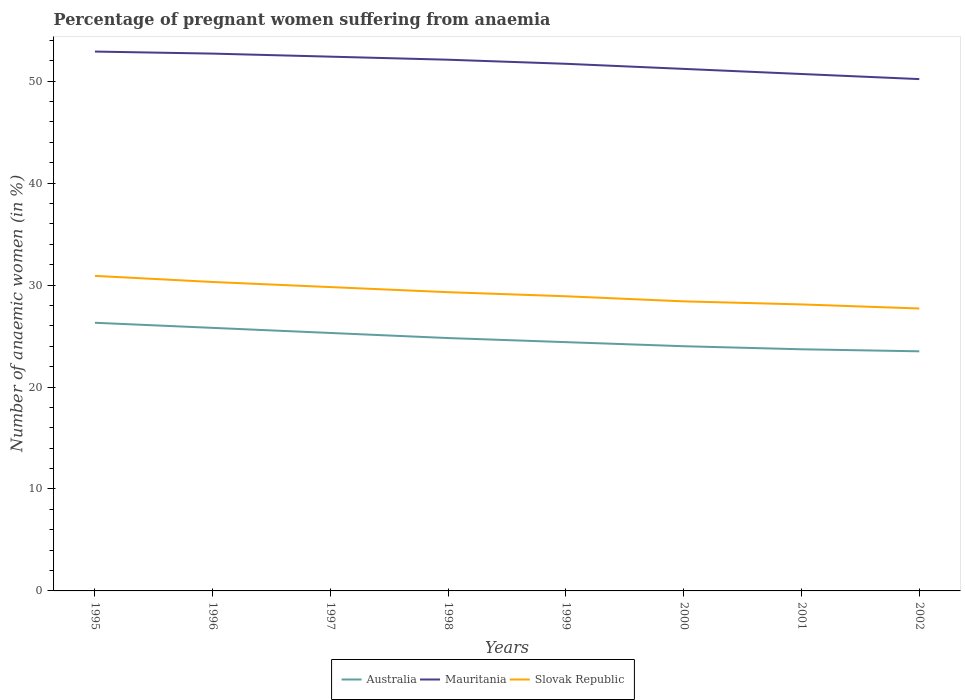Does the line corresponding to Mauritania intersect with the line corresponding to Australia?
Provide a short and direct response. No. Is the number of lines equal to the number of legend labels?
Your answer should be very brief. Yes. Across all years, what is the maximum number of anaemic women in Slovak Republic?
Offer a terse response. 27.7. In which year was the number of anaemic women in Australia maximum?
Your response must be concise. 2002. What is the total number of anaemic women in Mauritania in the graph?
Offer a very short reply. 0.6. What is the difference between the highest and the second highest number of anaemic women in Mauritania?
Your answer should be very brief. 2.7. What is the difference between the highest and the lowest number of anaemic women in Australia?
Make the answer very short. 4. How many lines are there?
Keep it short and to the point. 3. How many years are there in the graph?
Give a very brief answer. 8. What is the difference between two consecutive major ticks on the Y-axis?
Keep it short and to the point. 10. Are the values on the major ticks of Y-axis written in scientific E-notation?
Provide a short and direct response. No. Does the graph contain any zero values?
Your answer should be compact. No. Does the graph contain grids?
Provide a succinct answer. No. Where does the legend appear in the graph?
Offer a very short reply. Bottom center. How many legend labels are there?
Ensure brevity in your answer.  3. What is the title of the graph?
Your response must be concise. Percentage of pregnant women suffering from anaemia. Does "Virgin Islands" appear as one of the legend labels in the graph?
Provide a short and direct response. No. What is the label or title of the X-axis?
Keep it short and to the point. Years. What is the label or title of the Y-axis?
Ensure brevity in your answer.  Number of anaemic women (in %). What is the Number of anaemic women (in %) in Australia in 1995?
Your answer should be very brief. 26.3. What is the Number of anaemic women (in %) in Mauritania in 1995?
Keep it short and to the point. 52.9. What is the Number of anaemic women (in %) in Slovak Republic in 1995?
Offer a terse response. 30.9. What is the Number of anaemic women (in %) of Australia in 1996?
Provide a succinct answer. 25.8. What is the Number of anaemic women (in %) in Mauritania in 1996?
Make the answer very short. 52.7. What is the Number of anaemic women (in %) of Slovak Republic in 1996?
Your answer should be compact. 30.3. What is the Number of anaemic women (in %) in Australia in 1997?
Provide a succinct answer. 25.3. What is the Number of anaemic women (in %) in Mauritania in 1997?
Give a very brief answer. 52.4. What is the Number of anaemic women (in %) in Slovak Republic in 1997?
Ensure brevity in your answer.  29.8. What is the Number of anaemic women (in %) in Australia in 1998?
Offer a terse response. 24.8. What is the Number of anaemic women (in %) in Mauritania in 1998?
Offer a terse response. 52.1. What is the Number of anaemic women (in %) in Slovak Republic in 1998?
Your answer should be compact. 29.3. What is the Number of anaemic women (in %) of Australia in 1999?
Your answer should be compact. 24.4. What is the Number of anaemic women (in %) in Mauritania in 1999?
Your answer should be compact. 51.7. What is the Number of anaemic women (in %) in Slovak Republic in 1999?
Make the answer very short. 28.9. What is the Number of anaemic women (in %) of Australia in 2000?
Give a very brief answer. 24. What is the Number of anaemic women (in %) in Mauritania in 2000?
Your answer should be compact. 51.2. What is the Number of anaemic women (in %) of Slovak Republic in 2000?
Provide a short and direct response. 28.4. What is the Number of anaemic women (in %) of Australia in 2001?
Make the answer very short. 23.7. What is the Number of anaemic women (in %) of Mauritania in 2001?
Provide a short and direct response. 50.7. What is the Number of anaemic women (in %) of Slovak Republic in 2001?
Keep it short and to the point. 28.1. What is the Number of anaemic women (in %) of Mauritania in 2002?
Offer a very short reply. 50.2. What is the Number of anaemic women (in %) in Slovak Republic in 2002?
Your answer should be very brief. 27.7. Across all years, what is the maximum Number of anaemic women (in %) in Australia?
Your answer should be very brief. 26.3. Across all years, what is the maximum Number of anaemic women (in %) in Mauritania?
Give a very brief answer. 52.9. Across all years, what is the maximum Number of anaemic women (in %) of Slovak Republic?
Offer a terse response. 30.9. Across all years, what is the minimum Number of anaemic women (in %) of Mauritania?
Make the answer very short. 50.2. Across all years, what is the minimum Number of anaemic women (in %) in Slovak Republic?
Offer a very short reply. 27.7. What is the total Number of anaemic women (in %) of Australia in the graph?
Ensure brevity in your answer.  197.8. What is the total Number of anaemic women (in %) of Mauritania in the graph?
Provide a short and direct response. 413.9. What is the total Number of anaemic women (in %) of Slovak Republic in the graph?
Your answer should be compact. 233.4. What is the difference between the Number of anaemic women (in %) of Slovak Republic in 1995 and that in 1997?
Ensure brevity in your answer.  1.1. What is the difference between the Number of anaemic women (in %) in Australia in 1995 and that in 1998?
Make the answer very short. 1.5. What is the difference between the Number of anaemic women (in %) of Slovak Republic in 1995 and that in 1998?
Offer a terse response. 1.6. What is the difference between the Number of anaemic women (in %) in Slovak Republic in 1995 and that in 1999?
Make the answer very short. 2. What is the difference between the Number of anaemic women (in %) in Australia in 1995 and that in 2000?
Offer a very short reply. 2.3. What is the difference between the Number of anaemic women (in %) of Mauritania in 1995 and that in 2000?
Provide a succinct answer. 1.7. What is the difference between the Number of anaemic women (in %) in Slovak Republic in 1995 and that in 2000?
Your response must be concise. 2.5. What is the difference between the Number of anaemic women (in %) in Australia in 1995 and that in 2002?
Your answer should be compact. 2.8. What is the difference between the Number of anaemic women (in %) in Mauritania in 1995 and that in 2002?
Ensure brevity in your answer.  2.7. What is the difference between the Number of anaemic women (in %) of Slovak Republic in 1995 and that in 2002?
Provide a succinct answer. 3.2. What is the difference between the Number of anaemic women (in %) of Mauritania in 1996 and that in 1997?
Your response must be concise. 0.3. What is the difference between the Number of anaemic women (in %) of Slovak Republic in 1996 and that in 1997?
Offer a very short reply. 0.5. What is the difference between the Number of anaemic women (in %) of Australia in 1996 and that in 1998?
Your answer should be compact. 1. What is the difference between the Number of anaemic women (in %) of Australia in 1996 and that in 1999?
Give a very brief answer. 1.4. What is the difference between the Number of anaemic women (in %) in Slovak Republic in 1996 and that in 1999?
Ensure brevity in your answer.  1.4. What is the difference between the Number of anaemic women (in %) in Australia in 1996 and that in 2000?
Offer a very short reply. 1.8. What is the difference between the Number of anaemic women (in %) of Slovak Republic in 1996 and that in 2000?
Your answer should be compact. 1.9. What is the difference between the Number of anaemic women (in %) in Slovak Republic in 1996 and that in 2001?
Provide a short and direct response. 2.2. What is the difference between the Number of anaemic women (in %) of Mauritania in 1996 and that in 2002?
Your answer should be very brief. 2.5. What is the difference between the Number of anaemic women (in %) in Slovak Republic in 1996 and that in 2002?
Keep it short and to the point. 2.6. What is the difference between the Number of anaemic women (in %) of Australia in 1997 and that in 1998?
Keep it short and to the point. 0.5. What is the difference between the Number of anaemic women (in %) of Mauritania in 1997 and that in 1998?
Provide a short and direct response. 0.3. What is the difference between the Number of anaemic women (in %) of Australia in 1997 and that in 1999?
Your response must be concise. 0.9. What is the difference between the Number of anaemic women (in %) in Mauritania in 1997 and that in 1999?
Give a very brief answer. 0.7. What is the difference between the Number of anaemic women (in %) of Australia in 1997 and that in 2000?
Provide a succinct answer. 1.3. What is the difference between the Number of anaemic women (in %) of Mauritania in 1997 and that in 2000?
Your answer should be compact. 1.2. What is the difference between the Number of anaemic women (in %) in Slovak Republic in 1997 and that in 2000?
Offer a terse response. 1.4. What is the difference between the Number of anaemic women (in %) in Mauritania in 1997 and that in 2001?
Your answer should be compact. 1.7. What is the difference between the Number of anaemic women (in %) of Australia in 1997 and that in 2002?
Offer a very short reply. 1.8. What is the difference between the Number of anaemic women (in %) in Australia in 1998 and that in 1999?
Your response must be concise. 0.4. What is the difference between the Number of anaemic women (in %) of Slovak Republic in 1998 and that in 1999?
Your answer should be very brief. 0.4. What is the difference between the Number of anaemic women (in %) in Mauritania in 1998 and that in 2000?
Offer a very short reply. 0.9. What is the difference between the Number of anaemic women (in %) of Slovak Republic in 1998 and that in 2000?
Give a very brief answer. 0.9. What is the difference between the Number of anaemic women (in %) in Australia in 1998 and that in 2001?
Provide a succinct answer. 1.1. What is the difference between the Number of anaemic women (in %) in Mauritania in 1998 and that in 2001?
Offer a very short reply. 1.4. What is the difference between the Number of anaemic women (in %) of Slovak Republic in 1998 and that in 2001?
Give a very brief answer. 1.2. What is the difference between the Number of anaemic women (in %) in Mauritania in 1998 and that in 2002?
Provide a succinct answer. 1.9. What is the difference between the Number of anaemic women (in %) in Slovak Republic in 1998 and that in 2002?
Your response must be concise. 1.6. What is the difference between the Number of anaemic women (in %) in Slovak Republic in 1999 and that in 2001?
Provide a succinct answer. 0.8. What is the difference between the Number of anaemic women (in %) of Australia in 1999 and that in 2002?
Keep it short and to the point. 0.9. What is the difference between the Number of anaemic women (in %) in Slovak Republic in 1999 and that in 2002?
Give a very brief answer. 1.2. What is the difference between the Number of anaemic women (in %) in Mauritania in 2001 and that in 2002?
Make the answer very short. 0.5. What is the difference between the Number of anaemic women (in %) in Australia in 1995 and the Number of anaemic women (in %) in Mauritania in 1996?
Your answer should be very brief. -26.4. What is the difference between the Number of anaemic women (in %) of Mauritania in 1995 and the Number of anaemic women (in %) of Slovak Republic in 1996?
Provide a short and direct response. 22.6. What is the difference between the Number of anaemic women (in %) of Australia in 1995 and the Number of anaemic women (in %) of Mauritania in 1997?
Offer a terse response. -26.1. What is the difference between the Number of anaemic women (in %) of Australia in 1995 and the Number of anaemic women (in %) of Slovak Republic in 1997?
Provide a succinct answer. -3.5. What is the difference between the Number of anaemic women (in %) in Mauritania in 1995 and the Number of anaemic women (in %) in Slovak Republic in 1997?
Offer a very short reply. 23.1. What is the difference between the Number of anaemic women (in %) in Australia in 1995 and the Number of anaemic women (in %) in Mauritania in 1998?
Your answer should be very brief. -25.8. What is the difference between the Number of anaemic women (in %) of Mauritania in 1995 and the Number of anaemic women (in %) of Slovak Republic in 1998?
Ensure brevity in your answer.  23.6. What is the difference between the Number of anaemic women (in %) of Australia in 1995 and the Number of anaemic women (in %) of Mauritania in 1999?
Make the answer very short. -25.4. What is the difference between the Number of anaemic women (in %) in Australia in 1995 and the Number of anaemic women (in %) in Mauritania in 2000?
Ensure brevity in your answer.  -24.9. What is the difference between the Number of anaemic women (in %) in Mauritania in 1995 and the Number of anaemic women (in %) in Slovak Republic in 2000?
Make the answer very short. 24.5. What is the difference between the Number of anaemic women (in %) in Australia in 1995 and the Number of anaemic women (in %) in Mauritania in 2001?
Your response must be concise. -24.4. What is the difference between the Number of anaemic women (in %) in Mauritania in 1995 and the Number of anaemic women (in %) in Slovak Republic in 2001?
Provide a succinct answer. 24.8. What is the difference between the Number of anaemic women (in %) of Australia in 1995 and the Number of anaemic women (in %) of Mauritania in 2002?
Provide a succinct answer. -23.9. What is the difference between the Number of anaemic women (in %) of Mauritania in 1995 and the Number of anaemic women (in %) of Slovak Republic in 2002?
Provide a short and direct response. 25.2. What is the difference between the Number of anaemic women (in %) in Australia in 1996 and the Number of anaemic women (in %) in Mauritania in 1997?
Your answer should be compact. -26.6. What is the difference between the Number of anaemic women (in %) in Australia in 1996 and the Number of anaemic women (in %) in Slovak Republic in 1997?
Give a very brief answer. -4. What is the difference between the Number of anaemic women (in %) in Mauritania in 1996 and the Number of anaemic women (in %) in Slovak Republic in 1997?
Ensure brevity in your answer.  22.9. What is the difference between the Number of anaemic women (in %) of Australia in 1996 and the Number of anaemic women (in %) of Mauritania in 1998?
Provide a succinct answer. -26.3. What is the difference between the Number of anaemic women (in %) in Mauritania in 1996 and the Number of anaemic women (in %) in Slovak Republic in 1998?
Make the answer very short. 23.4. What is the difference between the Number of anaemic women (in %) in Australia in 1996 and the Number of anaemic women (in %) in Mauritania in 1999?
Your answer should be compact. -25.9. What is the difference between the Number of anaemic women (in %) in Australia in 1996 and the Number of anaemic women (in %) in Slovak Republic in 1999?
Make the answer very short. -3.1. What is the difference between the Number of anaemic women (in %) in Mauritania in 1996 and the Number of anaemic women (in %) in Slovak Republic in 1999?
Your response must be concise. 23.8. What is the difference between the Number of anaemic women (in %) of Australia in 1996 and the Number of anaemic women (in %) of Mauritania in 2000?
Offer a terse response. -25.4. What is the difference between the Number of anaemic women (in %) in Mauritania in 1996 and the Number of anaemic women (in %) in Slovak Republic in 2000?
Provide a short and direct response. 24.3. What is the difference between the Number of anaemic women (in %) of Australia in 1996 and the Number of anaemic women (in %) of Mauritania in 2001?
Your response must be concise. -24.9. What is the difference between the Number of anaemic women (in %) in Mauritania in 1996 and the Number of anaemic women (in %) in Slovak Republic in 2001?
Provide a short and direct response. 24.6. What is the difference between the Number of anaemic women (in %) in Australia in 1996 and the Number of anaemic women (in %) in Mauritania in 2002?
Your answer should be compact. -24.4. What is the difference between the Number of anaemic women (in %) in Australia in 1996 and the Number of anaemic women (in %) in Slovak Republic in 2002?
Offer a terse response. -1.9. What is the difference between the Number of anaemic women (in %) of Australia in 1997 and the Number of anaemic women (in %) of Mauritania in 1998?
Provide a short and direct response. -26.8. What is the difference between the Number of anaemic women (in %) of Mauritania in 1997 and the Number of anaemic women (in %) of Slovak Republic in 1998?
Give a very brief answer. 23.1. What is the difference between the Number of anaemic women (in %) of Australia in 1997 and the Number of anaemic women (in %) of Mauritania in 1999?
Your response must be concise. -26.4. What is the difference between the Number of anaemic women (in %) of Australia in 1997 and the Number of anaemic women (in %) of Slovak Republic in 1999?
Provide a short and direct response. -3.6. What is the difference between the Number of anaemic women (in %) of Australia in 1997 and the Number of anaemic women (in %) of Mauritania in 2000?
Offer a terse response. -25.9. What is the difference between the Number of anaemic women (in %) of Australia in 1997 and the Number of anaemic women (in %) of Slovak Republic in 2000?
Keep it short and to the point. -3.1. What is the difference between the Number of anaemic women (in %) in Australia in 1997 and the Number of anaemic women (in %) in Mauritania in 2001?
Give a very brief answer. -25.4. What is the difference between the Number of anaemic women (in %) of Australia in 1997 and the Number of anaemic women (in %) of Slovak Republic in 2001?
Offer a very short reply. -2.8. What is the difference between the Number of anaemic women (in %) in Mauritania in 1997 and the Number of anaemic women (in %) in Slovak Republic in 2001?
Your answer should be very brief. 24.3. What is the difference between the Number of anaemic women (in %) of Australia in 1997 and the Number of anaemic women (in %) of Mauritania in 2002?
Keep it short and to the point. -24.9. What is the difference between the Number of anaemic women (in %) in Australia in 1997 and the Number of anaemic women (in %) in Slovak Republic in 2002?
Give a very brief answer. -2.4. What is the difference between the Number of anaemic women (in %) of Mauritania in 1997 and the Number of anaemic women (in %) of Slovak Republic in 2002?
Ensure brevity in your answer.  24.7. What is the difference between the Number of anaemic women (in %) of Australia in 1998 and the Number of anaemic women (in %) of Mauritania in 1999?
Your answer should be very brief. -26.9. What is the difference between the Number of anaemic women (in %) in Australia in 1998 and the Number of anaemic women (in %) in Slovak Republic in 1999?
Provide a succinct answer. -4.1. What is the difference between the Number of anaemic women (in %) in Mauritania in 1998 and the Number of anaemic women (in %) in Slovak Republic in 1999?
Ensure brevity in your answer.  23.2. What is the difference between the Number of anaemic women (in %) in Australia in 1998 and the Number of anaemic women (in %) in Mauritania in 2000?
Ensure brevity in your answer.  -26.4. What is the difference between the Number of anaemic women (in %) in Mauritania in 1998 and the Number of anaemic women (in %) in Slovak Republic in 2000?
Your answer should be compact. 23.7. What is the difference between the Number of anaemic women (in %) of Australia in 1998 and the Number of anaemic women (in %) of Mauritania in 2001?
Offer a very short reply. -25.9. What is the difference between the Number of anaemic women (in %) in Australia in 1998 and the Number of anaemic women (in %) in Slovak Republic in 2001?
Provide a succinct answer. -3.3. What is the difference between the Number of anaemic women (in %) of Mauritania in 1998 and the Number of anaemic women (in %) of Slovak Republic in 2001?
Keep it short and to the point. 24. What is the difference between the Number of anaemic women (in %) in Australia in 1998 and the Number of anaemic women (in %) in Mauritania in 2002?
Provide a short and direct response. -25.4. What is the difference between the Number of anaemic women (in %) in Mauritania in 1998 and the Number of anaemic women (in %) in Slovak Republic in 2002?
Your answer should be very brief. 24.4. What is the difference between the Number of anaemic women (in %) of Australia in 1999 and the Number of anaemic women (in %) of Mauritania in 2000?
Offer a very short reply. -26.8. What is the difference between the Number of anaemic women (in %) of Mauritania in 1999 and the Number of anaemic women (in %) of Slovak Republic in 2000?
Ensure brevity in your answer.  23.3. What is the difference between the Number of anaemic women (in %) of Australia in 1999 and the Number of anaemic women (in %) of Mauritania in 2001?
Provide a succinct answer. -26.3. What is the difference between the Number of anaemic women (in %) in Australia in 1999 and the Number of anaemic women (in %) in Slovak Republic in 2001?
Offer a very short reply. -3.7. What is the difference between the Number of anaemic women (in %) in Mauritania in 1999 and the Number of anaemic women (in %) in Slovak Republic in 2001?
Ensure brevity in your answer.  23.6. What is the difference between the Number of anaemic women (in %) of Australia in 1999 and the Number of anaemic women (in %) of Mauritania in 2002?
Provide a succinct answer. -25.8. What is the difference between the Number of anaemic women (in %) in Mauritania in 1999 and the Number of anaemic women (in %) in Slovak Republic in 2002?
Your response must be concise. 24. What is the difference between the Number of anaemic women (in %) in Australia in 2000 and the Number of anaemic women (in %) in Mauritania in 2001?
Make the answer very short. -26.7. What is the difference between the Number of anaemic women (in %) in Mauritania in 2000 and the Number of anaemic women (in %) in Slovak Republic in 2001?
Your answer should be very brief. 23.1. What is the difference between the Number of anaemic women (in %) in Australia in 2000 and the Number of anaemic women (in %) in Mauritania in 2002?
Provide a short and direct response. -26.2. What is the difference between the Number of anaemic women (in %) in Australia in 2000 and the Number of anaemic women (in %) in Slovak Republic in 2002?
Offer a terse response. -3.7. What is the difference between the Number of anaemic women (in %) of Mauritania in 2000 and the Number of anaemic women (in %) of Slovak Republic in 2002?
Your answer should be compact. 23.5. What is the difference between the Number of anaemic women (in %) of Australia in 2001 and the Number of anaemic women (in %) of Mauritania in 2002?
Give a very brief answer. -26.5. What is the difference between the Number of anaemic women (in %) in Australia in 2001 and the Number of anaemic women (in %) in Slovak Republic in 2002?
Provide a short and direct response. -4. What is the average Number of anaemic women (in %) of Australia per year?
Provide a short and direct response. 24.73. What is the average Number of anaemic women (in %) in Mauritania per year?
Your response must be concise. 51.74. What is the average Number of anaemic women (in %) of Slovak Republic per year?
Keep it short and to the point. 29.18. In the year 1995, what is the difference between the Number of anaemic women (in %) in Australia and Number of anaemic women (in %) in Mauritania?
Your response must be concise. -26.6. In the year 1995, what is the difference between the Number of anaemic women (in %) of Mauritania and Number of anaemic women (in %) of Slovak Republic?
Make the answer very short. 22. In the year 1996, what is the difference between the Number of anaemic women (in %) of Australia and Number of anaemic women (in %) of Mauritania?
Offer a very short reply. -26.9. In the year 1996, what is the difference between the Number of anaemic women (in %) in Australia and Number of anaemic women (in %) in Slovak Republic?
Make the answer very short. -4.5. In the year 1996, what is the difference between the Number of anaemic women (in %) of Mauritania and Number of anaemic women (in %) of Slovak Republic?
Provide a short and direct response. 22.4. In the year 1997, what is the difference between the Number of anaemic women (in %) of Australia and Number of anaemic women (in %) of Mauritania?
Your answer should be compact. -27.1. In the year 1997, what is the difference between the Number of anaemic women (in %) in Australia and Number of anaemic women (in %) in Slovak Republic?
Keep it short and to the point. -4.5. In the year 1997, what is the difference between the Number of anaemic women (in %) of Mauritania and Number of anaemic women (in %) of Slovak Republic?
Give a very brief answer. 22.6. In the year 1998, what is the difference between the Number of anaemic women (in %) in Australia and Number of anaemic women (in %) in Mauritania?
Provide a short and direct response. -27.3. In the year 1998, what is the difference between the Number of anaemic women (in %) in Australia and Number of anaemic women (in %) in Slovak Republic?
Keep it short and to the point. -4.5. In the year 1998, what is the difference between the Number of anaemic women (in %) in Mauritania and Number of anaemic women (in %) in Slovak Republic?
Offer a terse response. 22.8. In the year 1999, what is the difference between the Number of anaemic women (in %) of Australia and Number of anaemic women (in %) of Mauritania?
Your answer should be very brief. -27.3. In the year 1999, what is the difference between the Number of anaemic women (in %) of Mauritania and Number of anaemic women (in %) of Slovak Republic?
Make the answer very short. 22.8. In the year 2000, what is the difference between the Number of anaemic women (in %) of Australia and Number of anaemic women (in %) of Mauritania?
Your answer should be compact. -27.2. In the year 2000, what is the difference between the Number of anaemic women (in %) of Australia and Number of anaemic women (in %) of Slovak Republic?
Your answer should be very brief. -4.4. In the year 2000, what is the difference between the Number of anaemic women (in %) in Mauritania and Number of anaemic women (in %) in Slovak Republic?
Offer a very short reply. 22.8. In the year 2001, what is the difference between the Number of anaemic women (in %) in Australia and Number of anaemic women (in %) in Mauritania?
Give a very brief answer. -27. In the year 2001, what is the difference between the Number of anaemic women (in %) of Australia and Number of anaemic women (in %) of Slovak Republic?
Provide a short and direct response. -4.4. In the year 2001, what is the difference between the Number of anaemic women (in %) of Mauritania and Number of anaemic women (in %) of Slovak Republic?
Your answer should be very brief. 22.6. In the year 2002, what is the difference between the Number of anaemic women (in %) in Australia and Number of anaemic women (in %) in Mauritania?
Your answer should be compact. -26.7. In the year 2002, what is the difference between the Number of anaemic women (in %) in Mauritania and Number of anaemic women (in %) in Slovak Republic?
Provide a short and direct response. 22.5. What is the ratio of the Number of anaemic women (in %) in Australia in 1995 to that in 1996?
Your response must be concise. 1.02. What is the ratio of the Number of anaemic women (in %) of Slovak Republic in 1995 to that in 1996?
Provide a succinct answer. 1.02. What is the ratio of the Number of anaemic women (in %) of Australia in 1995 to that in 1997?
Your response must be concise. 1.04. What is the ratio of the Number of anaemic women (in %) of Mauritania in 1995 to that in 1997?
Offer a terse response. 1.01. What is the ratio of the Number of anaemic women (in %) of Slovak Republic in 1995 to that in 1997?
Ensure brevity in your answer.  1.04. What is the ratio of the Number of anaemic women (in %) in Australia in 1995 to that in 1998?
Your answer should be very brief. 1.06. What is the ratio of the Number of anaemic women (in %) in Mauritania in 1995 to that in 1998?
Provide a succinct answer. 1.02. What is the ratio of the Number of anaemic women (in %) in Slovak Republic in 1995 to that in 1998?
Keep it short and to the point. 1.05. What is the ratio of the Number of anaemic women (in %) of Australia in 1995 to that in 1999?
Give a very brief answer. 1.08. What is the ratio of the Number of anaemic women (in %) of Mauritania in 1995 to that in 1999?
Ensure brevity in your answer.  1.02. What is the ratio of the Number of anaemic women (in %) in Slovak Republic in 1995 to that in 1999?
Offer a very short reply. 1.07. What is the ratio of the Number of anaemic women (in %) in Australia in 1995 to that in 2000?
Offer a very short reply. 1.1. What is the ratio of the Number of anaemic women (in %) of Mauritania in 1995 to that in 2000?
Your answer should be compact. 1.03. What is the ratio of the Number of anaemic women (in %) in Slovak Republic in 1995 to that in 2000?
Your response must be concise. 1.09. What is the ratio of the Number of anaemic women (in %) in Australia in 1995 to that in 2001?
Make the answer very short. 1.11. What is the ratio of the Number of anaemic women (in %) of Mauritania in 1995 to that in 2001?
Provide a short and direct response. 1.04. What is the ratio of the Number of anaemic women (in %) in Slovak Republic in 1995 to that in 2001?
Your response must be concise. 1.1. What is the ratio of the Number of anaemic women (in %) of Australia in 1995 to that in 2002?
Provide a succinct answer. 1.12. What is the ratio of the Number of anaemic women (in %) of Mauritania in 1995 to that in 2002?
Keep it short and to the point. 1.05. What is the ratio of the Number of anaemic women (in %) in Slovak Republic in 1995 to that in 2002?
Give a very brief answer. 1.12. What is the ratio of the Number of anaemic women (in %) of Australia in 1996 to that in 1997?
Provide a short and direct response. 1.02. What is the ratio of the Number of anaemic women (in %) in Slovak Republic in 1996 to that in 1997?
Make the answer very short. 1.02. What is the ratio of the Number of anaemic women (in %) in Australia in 1996 to that in 1998?
Offer a very short reply. 1.04. What is the ratio of the Number of anaemic women (in %) in Mauritania in 1996 to that in 1998?
Your answer should be very brief. 1.01. What is the ratio of the Number of anaemic women (in %) of Slovak Republic in 1996 to that in 1998?
Your answer should be very brief. 1.03. What is the ratio of the Number of anaemic women (in %) in Australia in 1996 to that in 1999?
Offer a terse response. 1.06. What is the ratio of the Number of anaemic women (in %) of Mauritania in 1996 to that in 1999?
Offer a very short reply. 1.02. What is the ratio of the Number of anaemic women (in %) of Slovak Republic in 1996 to that in 1999?
Provide a succinct answer. 1.05. What is the ratio of the Number of anaemic women (in %) in Australia in 1996 to that in 2000?
Provide a succinct answer. 1.07. What is the ratio of the Number of anaemic women (in %) of Mauritania in 1996 to that in 2000?
Make the answer very short. 1.03. What is the ratio of the Number of anaemic women (in %) in Slovak Republic in 1996 to that in 2000?
Ensure brevity in your answer.  1.07. What is the ratio of the Number of anaemic women (in %) of Australia in 1996 to that in 2001?
Keep it short and to the point. 1.09. What is the ratio of the Number of anaemic women (in %) in Mauritania in 1996 to that in 2001?
Your answer should be very brief. 1.04. What is the ratio of the Number of anaemic women (in %) of Slovak Republic in 1996 to that in 2001?
Provide a short and direct response. 1.08. What is the ratio of the Number of anaemic women (in %) of Australia in 1996 to that in 2002?
Ensure brevity in your answer.  1.1. What is the ratio of the Number of anaemic women (in %) of Mauritania in 1996 to that in 2002?
Your answer should be compact. 1.05. What is the ratio of the Number of anaemic women (in %) in Slovak Republic in 1996 to that in 2002?
Provide a short and direct response. 1.09. What is the ratio of the Number of anaemic women (in %) in Australia in 1997 to that in 1998?
Give a very brief answer. 1.02. What is the ratio of the Number of anaemic women (in %) in Slovak Republic in 1997 to that in 1998?
Your answer should be very brief. 1.02. What is the ratio of the Number of anaemic women (in %) in Australia in 1997 to that in 1999?
Provide a succinct answer. 1.04. What is the ratio of the Number of anaemic women (in %) of Mauritania in 1997 to that in 1999?
Your answer should be compact. 1.01. What is the ratio of the Number of anaemic women (in %) of Slovak Republic in 1997 to that in 1999?
Provide a short and direct response. 1.03. What is the ratio of the Number of anaemic women (in %) of Australia in 1997 to that in 2000?
Offer a terse response. 1.05. What is the ratio of the Number of anaemic women (in %) in Mauritania in 1997 to that in 2000?
Your answer should be compact. 1.02. What is the ratio of the Number of anaemic women (in %) in Slovak Republic in 1997 to that in 2000?
Your answer should be compact. 1.05. What is the ratio of the Number of anaemic women (in %) of Australia in 1997 to that in 2001?
Your response must be concise. 1.07. What is the ratio of the Number of anaemic women (in %) in Mauritania in 1997 to that in 2001?
Provide a succinct answer. 1.03. What is the ratio of the Number of anaemic women (in %) in Slovak Republic in 1997 to that in 2001?
Your answer should be compact. 1.06. What is the ratio of the Number of anaemic women (in %) of Australia in 1997 to that in 2002?
Provide a short and direct response. 1.08. What is the ratio of the Number of anaemic women (in %) of Mauritania in 1997 to that in 2002?
Give a very brief answer. 1.04. What is the ratio of the Number of anaemic women (in %) of Slovak Republic in 1997 to that in 2002?
Provide a succinct answer. 1.08. What is the ratio of the Number of anaemic women (in %) in Australia in 1998 to that in 1999?
Your answer should be very brief. 1.02. What is the ratio of the Number of anaemic women (in %) of Mauritania in 1998 to that in 1999?
Offer a terse response. 1.01. What is the ratio of the Number of anaemic women (in %) in Slovak Republic in 1998 to that in 1999?
Your answer should be compact. 1.01. What is the ratio of the Number of anaemic women (in %) of Mauritania in 1998 to that in 2000?
Your response must be concise. 1.02. What is the ratio of the Number of anaemic women (in %) in Slovak Republic in 1998 to that in 2000?
Ensure brevity in your answer.  1.03. What is the ratio of the Number of anaemic women (in %) of Australia in 1998 to that in 2001?
Keep it short and to the point. 1.05. What is the ratio of the Number of anaemic women (in %) in Mauritania in 1998 to that in 2001?
Your response must be concise. 1.03. What is the ratio of the Number of anaemic women (in %) in Slovak Republic in 1998 to that in 2001?
Make the answer very short. 1.04. What is the ratio of the Number of anaemic women (in %) of Australia in 1998 to that in 2002?
Offer a very short reply. 1.06. What is the ratio of the Number of anaemic women (in %) in Mauritania in 1998 to that in 2002?
Keep it short and to the point. 1.04. What is the ratio of the Number of anaemic women (in %) in Slovak Republic in 1998 to that in 2002?
Provide a short and direct response. 1.06. What is the ratio of the Number of anaemic women (in %) in Australia in 1999 to that in 2000?
Offer a very short reply. 1.02. What is the ratio of the Number of anaemic women (in %) of Mauritania in 1999 to that in 2000?
Your answer should be compact. 1.01. What is the ratio of the Number of anaemic women (in %) in Slovak Republic in 1999 to that in 2000?
Offer a terse response. 1.02. What is the ratio of the Number of anaemic women (in %) in Australia in 1999 to that in 2001?
Make the answer very short. 1.03. What is the ratio of the Number of anaemic women (in %) of Mauritania in 1999 to that in 2001?
Your answer should be very brief. 1.02. What is the ratio of the Number of anaemic women (in %) of Slovak Republic in 1999 to that in 2001?
Make the answer very short. 1.03. What is the ratio of the Number of anaemic women (in %) in Australia in 1999 to that in 2002?
Provide a short and direct response. 1.04. What is the ratio of the Number of anaemic women (in %) in Mauritania in 1999 to that in 2002?
Keep it short and to the point. 1.03. What is the ratio of the Number of anaemic women (in %) in Slovak Republic in 1999 to that in 2002?
Your answer should be very brief. 1.04. What is the ratio of the Number of anaemic women (in %) in Australia in 2000 to that in 2001?
Your answer should be compact. 1.01. What is the ratio of the Number of anaemic women (in %) of Mauritania in 2000 to that in 2001?
Ensure brevity in your answer.  1.01. What is the ratio of the Number of anaemic women (in %) in Slovak Republic in 2000 to that in 2001?
Give a very brief answer. 1.01. What is the ratio of the Number of anaemic women (in %) of Australia in 2000 to that in 2002?
Give a very brief answer. 1.02. What is the ratio of the Number of anaemic women (in %) in Mauritania in 2000 to that in 2002?
Make the answer very short. 1.02. What is the ratio of the Number of anaemic women (in %) of Slovak Republic in 2000 to that in 2002?
Give a very brief answer. 1.03. What is the ratio of the Number of anaemic women (in %) in Australia in 2001 to that in 2002?
Give a very brief answer. 1.01. What is the ratio of the Number of anaemic women (in %) in Mauritania in 2001 to that in 2002?
Offer a terse response. 1.01. What is the ratio of the Number of anaemic women (in %) of Slovak Republic in 2001 to that in 2002?
Make the answer very short. 1.01. What is the difference between the highest and the second highest Number of anaemic women (in %) of Australia?
Your answer should be compact. 0.5. What is the difference between the highest and the second highest Number of anaemic women (in %) of Mauritania?
Provide a succinct answer. 0.2. What is the difference between the highest and the second highest Number of anaemic women (in %) of Slovak Republic?
Provide a short and direct response. 0.6. What is the difference between the highest and the lowest Number of anaemic women (in %) in Slovak Republic?
Your answer should be very brief. 3.2. 